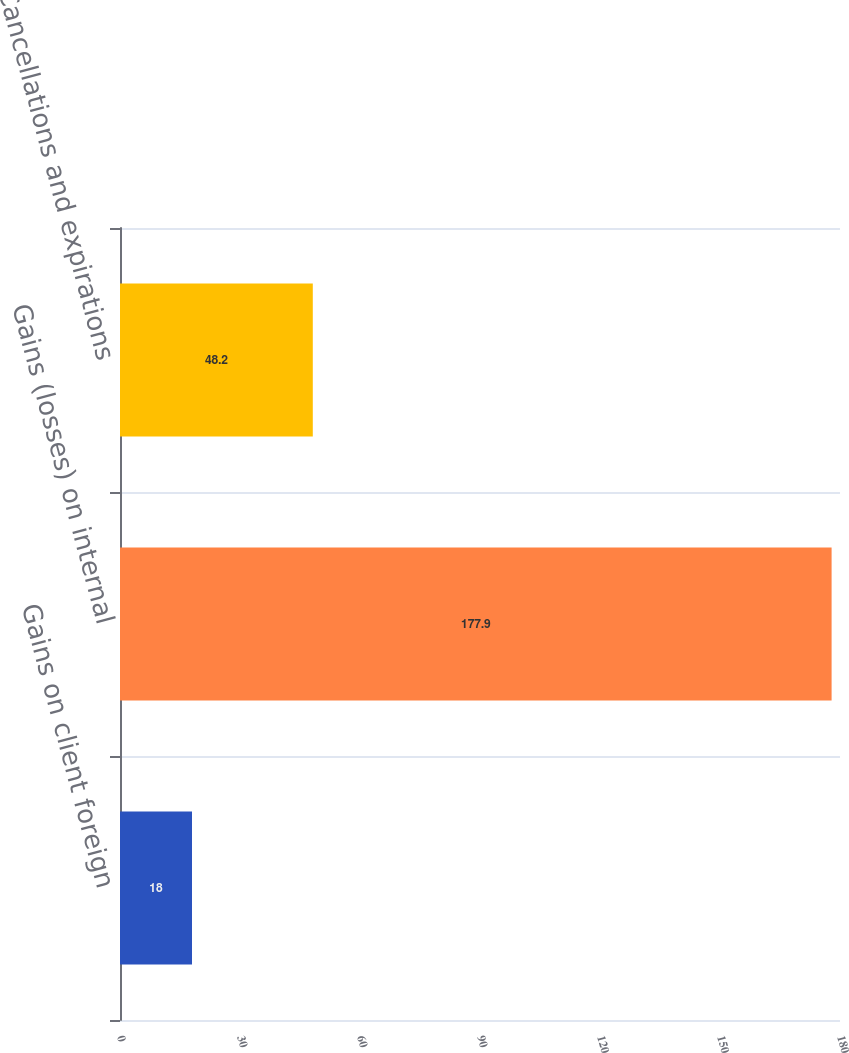Convert chart to OTSL. <chart><loc_0><loc_0><loc_500><loc_500><bar_chart><fcel>Gains on client foreign<fcel>Gains (losses) on internal<fcel>Cancellations and expirations<nl><fcel>18<fcel>177.9<fcel>48.2<nl></chart> 